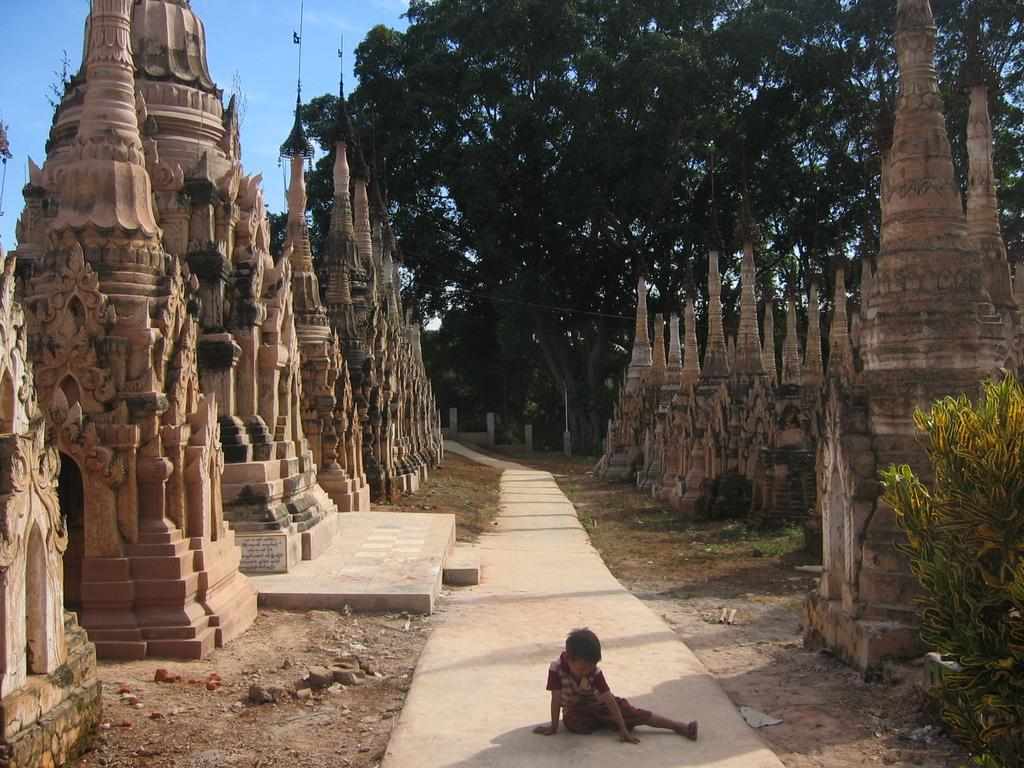What type of artwork is present in the image? There are sculptures in the image. Can you describe the person in the image? There is a person sitting at the bottom of the image. What can be seen in the background of the image? There are trees and the sky visible in the background of the image. What type of carpenter is working on the sculptures in the image? There is no carpenter present in the image, and sculptures do not require carpentry work. How many planes are flying in the sky in the image? There are no planes visible in the image; only trees and the sky are present in the background. 